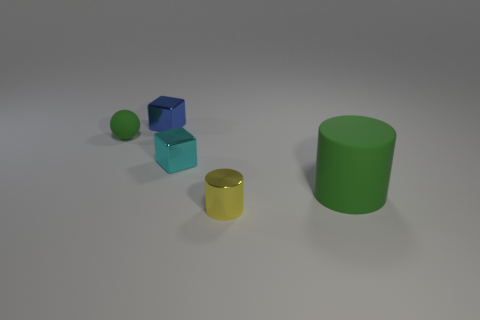Add 2 tiny metallic cylinders. How many objects exist? 7 Subtract all balls. How many objects are left? 4 Add 5 large brown rubber cylinders. How many large brown rubber cylinders exist? 5 Subtract 1 yellow cylinders. How many objects are left? 4 Subtract all green spheres. Subtract all brown matte cubes. How many objects are left? 4 Add 4 green things. How many green things are left? 6 